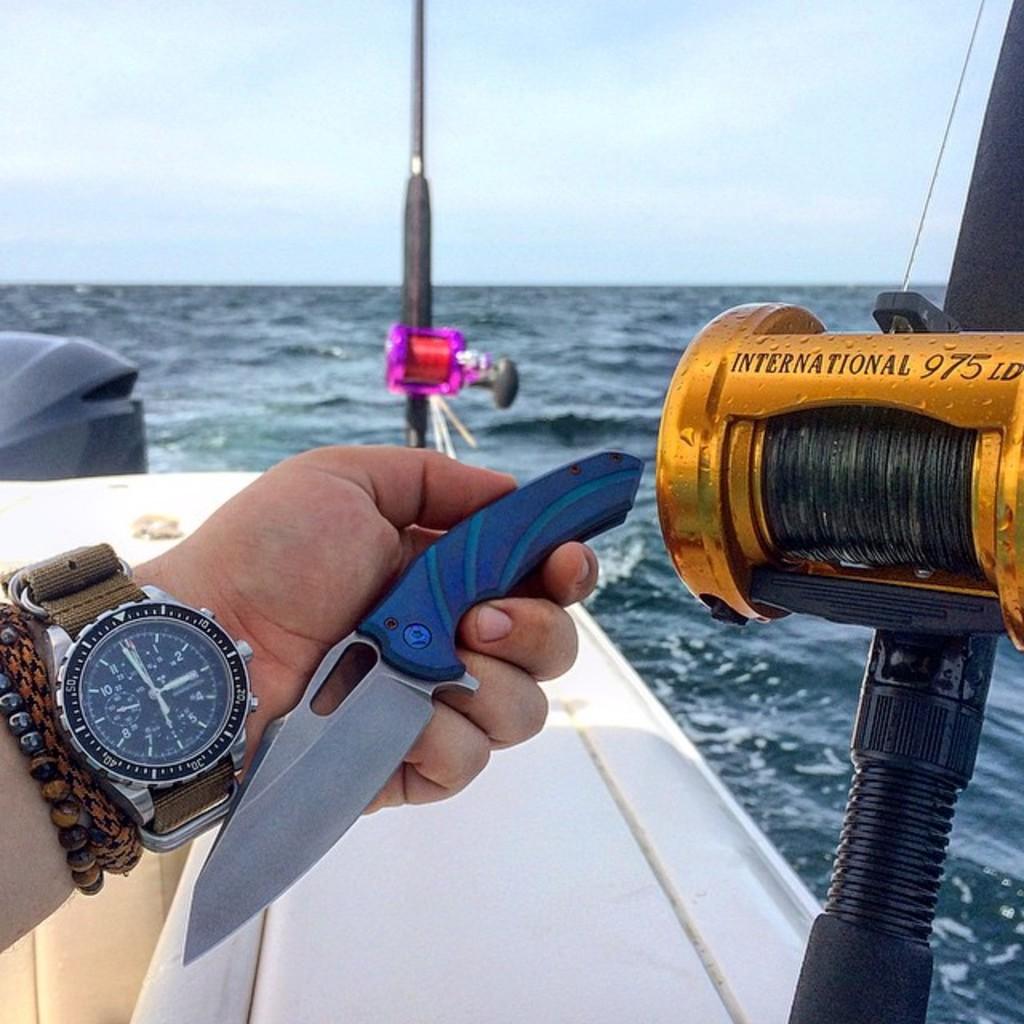What does the reel say?
Keep it short and to the point. International 975 ld. What is the 3 digit number written on the fishing poles reel?
Offer a terse response. 975. 